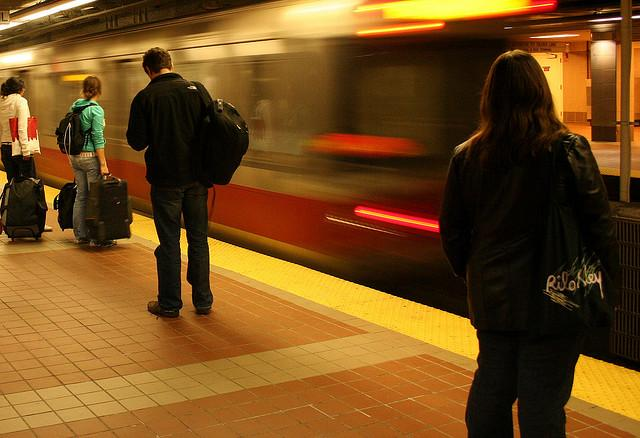What do the people do when the fast moving thing stops? get on 